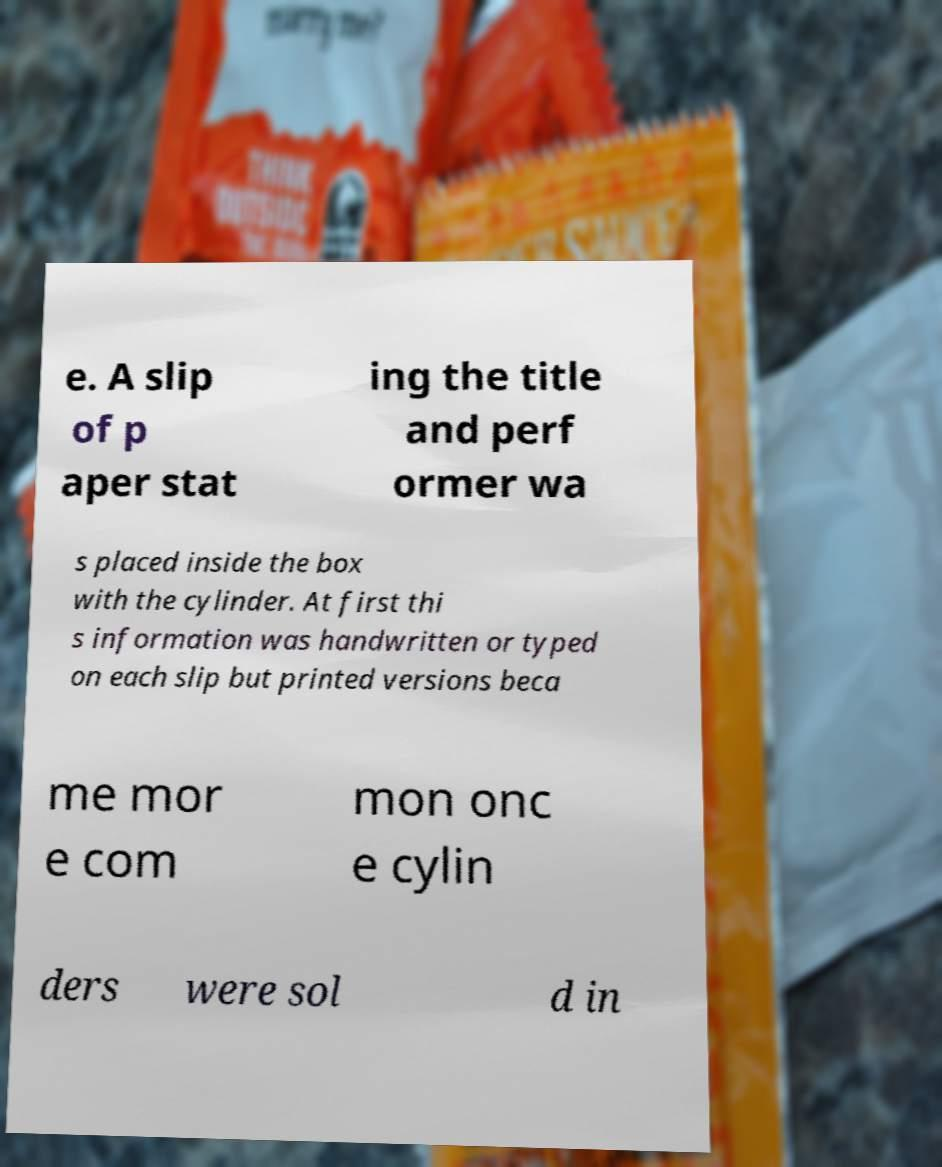Could you assist in decoding the text presented in this image and type it out clearly? e. A slip of p aper stat ing the title and perf ormer wa s placed inside the box with the cylinder. At first thi s information was handwritten or typed on each slip but printed versions beca me mor e com mon onc e cylin ders were sol d in 